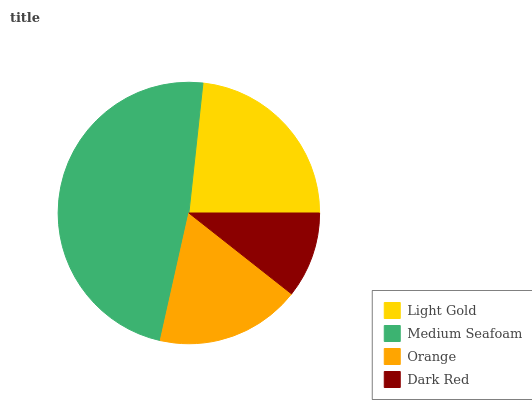Is Dark Red the minimum?
Answer yes or no. Yes. Is Medium Seafoam the maximum?
Answer yes or no. Yes. Is Orange the minimum?
Answer yes or no. No. Is Orange the maximum?
Answer yes or no. No. Is Medium Seafoam greater than Orange?
Answer yes or no. Yes. Is Orange less than Medium Seafoam?
Answer yes or no. Yes. Is Orange greater than Medium Seafoam?
Answer yes or no. No. Is Medium Seafoam less than Orange?
Answer yes or no. No. Is Light Gold the high median?
Answer yes or no. Yes. Is Orange the low median?
Answer yes or no. Yes. Is Dark Red the high median?
Answer yes or no. No. Is Dark Red the low median?
Answer yes or no. No. 